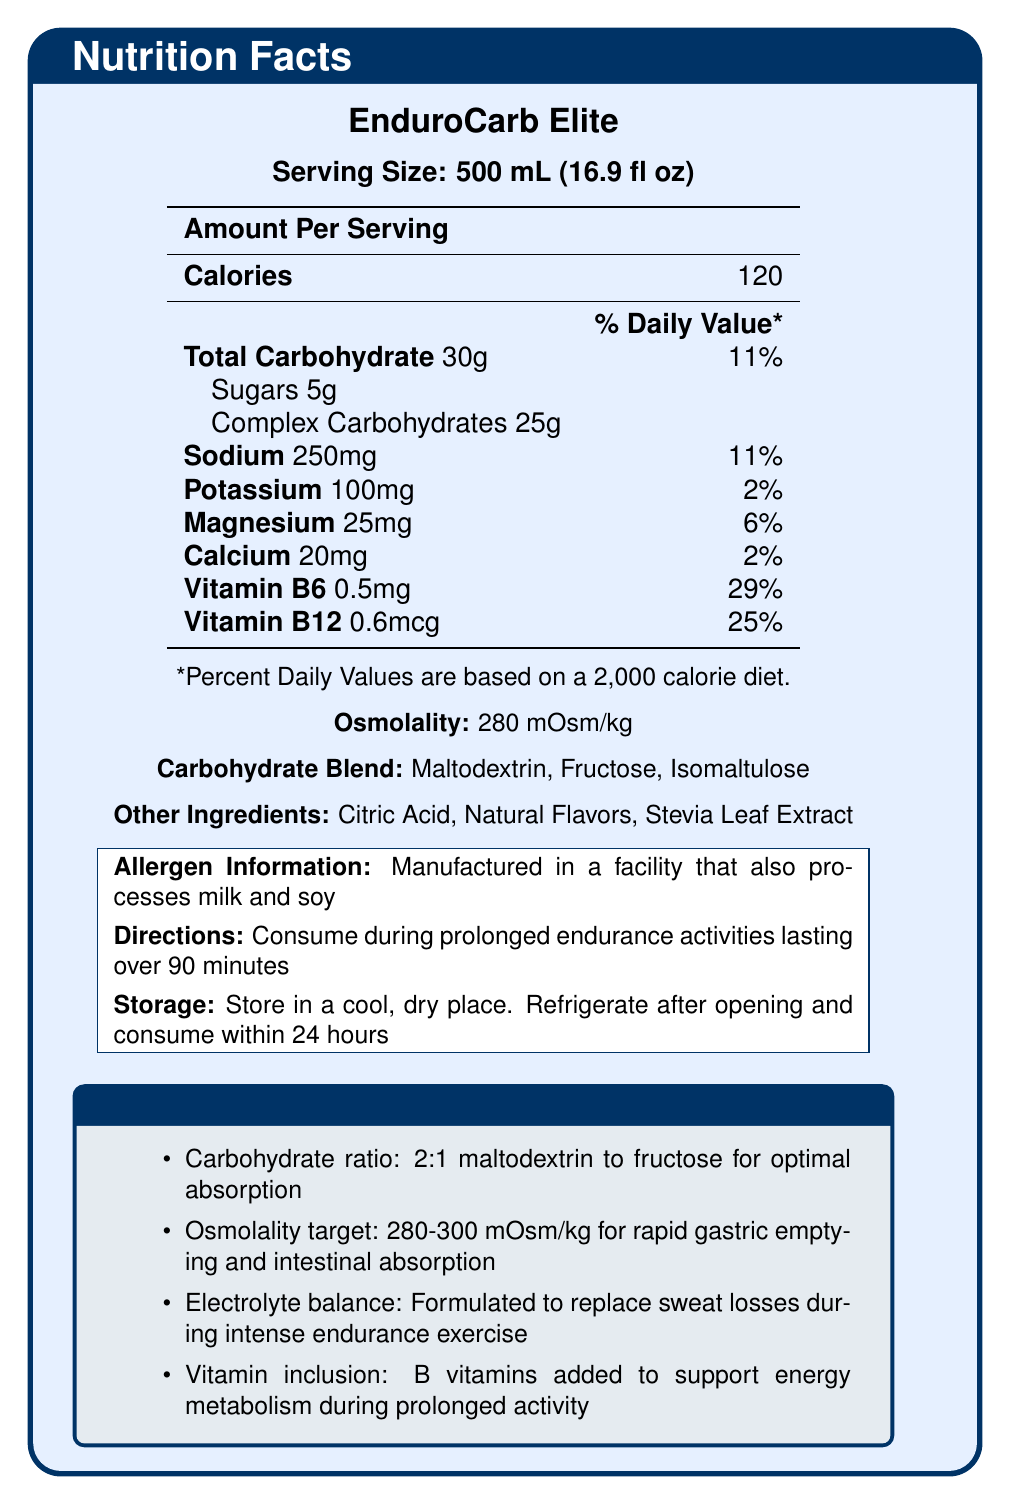What is the serving size of EnduroCarb Elite? The serving size is clearly mentioned on the document as "Serving Size: 500 mL (16.9 fl oz)".
Answer: 500 mL (16.9 fl oz) How many calories does one serving of EnduroCarb Elite contain? The document lists "Calories: 120" under "Amount Per Serving".
Answer: 120 What is the total carbohydrate content per serving? The total carbohydrate content is displayed as "Total Carbohydrate 30g".
Answer: 30g What is the osmolality of EnduroCarb Elite? The osmolality is listed in the document as "Osmolality: 280 mOsm/kg".
Answer: 280 mOsm/kg Which ingredient contributes to sweetness in EnduroCarb Elite? Stevia Leaf Extract is one of the listed "Other Ingredients" that likely contributes to sweetness.
Answer: Stevia Leaf Extract What percentage of the daily value for Vitamin B6 does EnduroCarb Elite provide? The document shows "Vitamin B6 0.5mg 29\%" under the % Daily Value section.
Answer: 29% What is the recommended time to consume EnduroCarb Elite? The directions state, "Consume during prolonged endurance activities lasting over 90 minutes".
Answer: During prolonged endurance activities lasting over 90 minutes Which of the following are part of the carbohydrate blend in EnduroCarb Elite? A. Maltodextrin B. Fructose C. Stevia Leaf Extract D. Isomaltulose The carbohydrate blend includes "Maltodextrin", "Fructose", and "Isomaltulose".
Answer: A, B, and D What is the primary purpose of the B vitamins included in EnduroCarb Elite? A. Support energy metabolism B. Enhance flavor C. Improve hydration D. Increase sweetness The document explains in the research notes that B vitamins are added to support energy metabolism during prolonged activity.
Answer: A. Support energy metabolism True or False: EnduroCarb Elite contains more sugars than complex carbohydrates? The document states "Sugars 5g" and "Complex Carbohydrates 25g", indicating more complex carbohydrates.
Answer: False Summarize the main nutritional features and recommendations provided for EnduroCarb Elite. The document details the nutritional content, including carbohydrates, electrolytes, and vitamins. It specifies the osmolality for hydration purposes, the carbohydrate blend for energy, and the intended use during long endurance activities. Storage instructions and allergen information are also provided.
Answer: Summary: The EnduroCarb Elite is a complex carbohydrate sports drink designed for use during prolonged endurance activities. It provides 120 calories per 500 mL serving and includes 30g of total carbohydrates, primarily from complex carbohydrates (25g) and sugars (5g). The electrolytes sodium, potassium, magnesium, and calcium help replace sweat losses. The osmolality is optimized at 280 mOsm/kg for rapid gastric emptying and absorption. Important vitamins like B6 and B12 support energy metabolism. The drink's formulation aims for optimal hydration and absorption during intense exercise sessions. How many grams of simple sugars are in a serving of EnduroCarb Elite? The document lists "Sugars 5g" under the carbohydrate content information.
Answer: 5g Is EnduroCarb Elite suitable for people with dairy allergies? The document mentions that it is "Manufactured in a facility that also processes milk and soy," which does not definitively indicate whether it is safe for someone with dairy allergies.
Answer: Not enough information What storage instructions are given for EnduroCarb Elite? The storage instructions are explicitly listed in the document.
Answer: Store in a cool, dry place. Refrigerate after opening and consume within 24 hours What is the sodium content per serving in EnduroCarb Elite? The sodium content per serving is specified in the document as "Sodium 250mg 11\%".
Answer: 250mg What ratio of maltodextrin to fructose is claimed to be optimal for absorption? A. 1:1 B. 2:1 C. 3:1 D. 1:2 The research notes state "Carbohydrate ratio: 2:1 maltodextrin to fructose for optimal absorption".
Answer: B. 2:1 